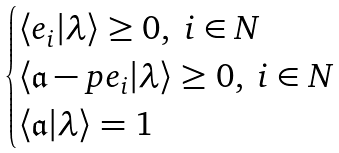Convert formula to latex. <formula><loc_0><loc_0><loc_500><loc_500>\begin{cases} \langle e _ { i } | \lambda \rangle \geq 0 , \ i \in N \\ \langle \mathfrak a - p e _ { i } | \lambda \rangle \geq 0 , \ i \in N \\ \langle \mathfrak a | \lambda \rangle = 1 \end{cases}</formula> 